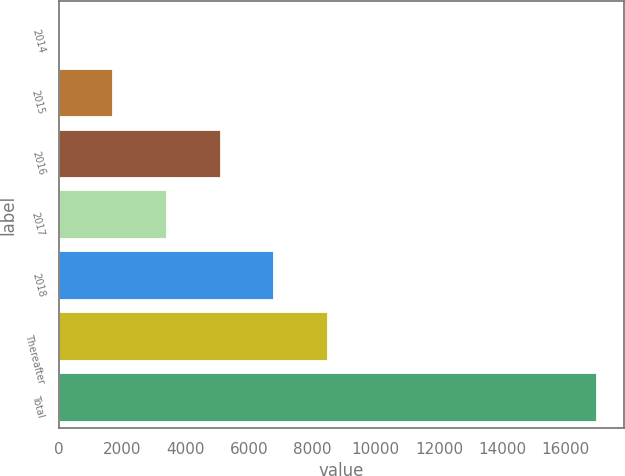Convert chart. <chart><loc_0><loc_0><loc_500><loc_500><bar_chart><fcel>2014<fcel>2015<fcel>2016<fcel>2017<fcel>2018<fcel>Thereafter<fcel>Total<nl><fcel>1.9<fcel>1701.71<fcel>5101.33<fcel>3401.52<fcel>6801.14<fcel>8500.95<fcel>17000<nl></chart> 